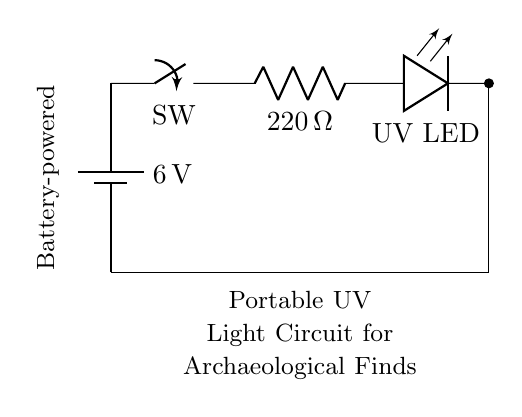What is the voltage of the battery in this circuit? The circuit diagram shows a battery labeled with a voltage of six volts, indicating the potential supplied to the circuit components.
Answer: six volts What is the value of the current-limiting resistor? In the circuit, the resistor is labeled with a value of two hundred twenty ohms, which indicates its resistance used to limit current to the UV LED.
Answer: two hundred twenty ohms What component is used as a switch in this circuit? The diagram shows a component labeled as a switch, which indicates it can open or close the circuit to control the flow of electricity.
Answer: switch What type of light does this circuit produce? The circuit includes an LED labeled specifically as a UV LED, indicating it emits ultraviolet light for detecting organic residues.
Answer: UV light Why is a current-limiting resistor necessary in this circuit? The current-limiting resistor is essential to prevent excessive current from flowing through the UV LED, which could otherwise damage it; thus, it ensures the LED operates safely within its specifications.
Answer: to protect the LED How is the circuit completed? The circuit is completed by connecting the wire from the UV LED's output back down to the battery, establishing a closed loop that allows current to flow from the battery through the LED and back again.
Answer: through the wire connections 